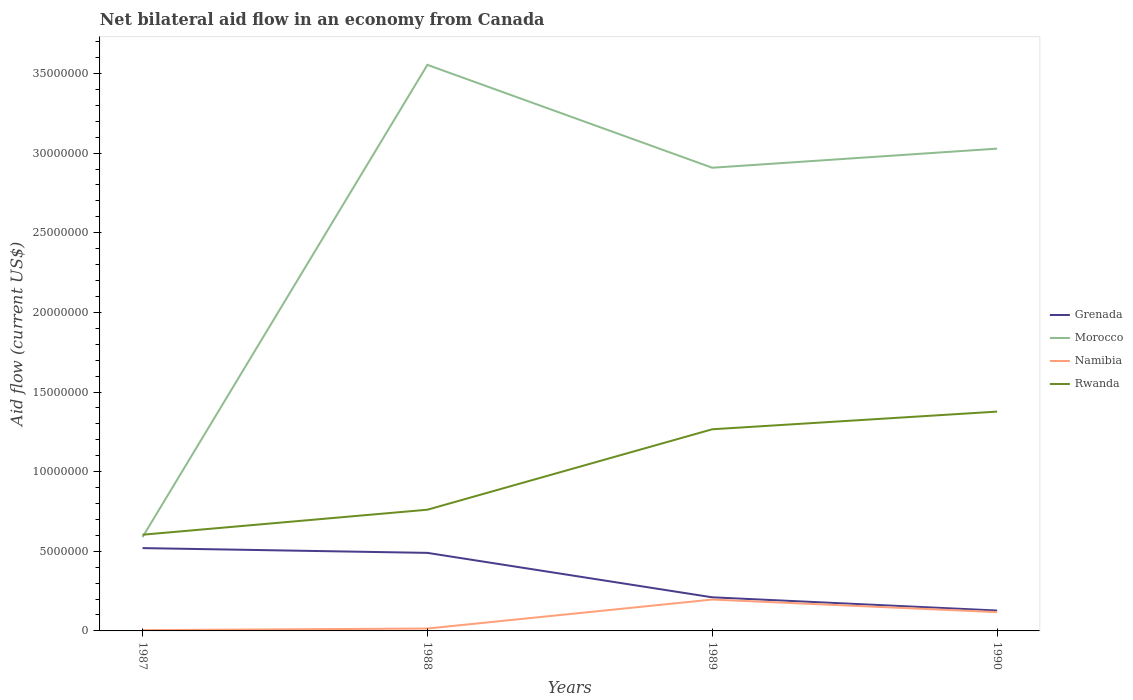Does the line corresponding to Morocco intersect with the line corresponding to Rwanda?
Offer a very short reply. Yes. Across all years, what is the maximum net bilateral aid flow in Rwanda?
Your answer should be very brief. 6.04e+06. What is the total net bilateral aid flow in Namibia in the graph?
Your answer should be very brief. -1.82e+06. What is the difference between the highest and the second highest net bilateral aid flow in Grenada?
Your answer should be compact. 3.92e+06. What is the difference between the highest and the lowest net bilateral aid flow in Namibia?
Offer a terse response. 2. How many years are there in the graph?
Offer a terse response. 4. What is the difference between two consecutive major ticks on the Y-axis?
Provide a succinct answer. 5.00e+06. Are the values on the major ticks of Y-axis written in scientific E-notation?
Keep it short and to the point. No. Does the graph contain any zero values?
Offer a very short reply. No. Where does the legend appear in the graph?
Your answer should be compact. Center right. How many legend labels are there?
Offer a terse response. 4. How are the legend labels stacked?
Offer a very short reply. Vertical. What is the title of the graph?
Make the answer very short. Net bilateral aid flow in an economy from Canada. Does "Congo (Republic)" appear as one of the legend labels in the graph?
Your response must be concise. No. What is the Aid flow (current US$) in Grenada in 1987?
Provide a succinct answer. 5.20e+06. What is the Aid flow (current US$) in Morocco in 1987?
Provide a succinct answer. 5.89e+06. What is the Aid flow (current US$) in Namibia in 1987?
Make the answer very short. 5.00e+04. What is the Aid flow (current US$) of Rwanda in 1987?
Ensure brevity in your answer.  6.04e+06. What is the Aid flow (current US$) of Grenada in 1988?
Make the answer very short. 4.90e+06. What is the Aid flow (current US$) in Morocco in 1988?
Make the answer very short. 3.55e+07. What is the Aid flow (current US$) in Rwanda in 1988?
Offer a very short reply. 7.61e+06. What is the Aid flow (current US$) in Grenada in 1989?
Provide a short and direct response. 2.11e+06. What is the Aid flow (current US$) in Morocco in 1989?
Offer a very short reply. 2.91e+07. What is the Aid flow (current US$) in Namibia in 1989?
Your answer should be compact. 1.97e+06. What is the Aid flow (current US$) of Rwanda in 1989?
Provide a short and direct response. 1.27e+07. What is the Aid flow (current US$) in Grenada in 1990?
Your answer should be compact. 1.28e+06. What is the Aid flow (current US$) in Morocco in 1990?
Provide a short and direct response. 3.03e+07. What is the Aid flow (current US$) in Namibia in 1990?
Offer a terse response. 1.18e+06. What is the Aid flow (current US$) in Rwanda in 1990?
Give a very brief answer. 1.38e+07. Across all years, what is the maximum Aid flow (current US$) of Grenada?
Your response must be concise. 5.20e+06. Across all years, what is the maximum Aid flow (current US$) in Morocco?
Offer a very short reply. 3.55e+07. Across all years, what is the maximum Aid flow (current US$) of Namibia?
Provide a short and direct response. 1.97e+06. Across all years, what is the maximum Aid flow (current US$) in Rwanda?
Ensure brevity in your answer.  1.38e+07. Across all years, what is the minimum Aid flow (current US$) in Grenada?
Provide a short and direct response. 1.28e+06. Across all years, what is the minimum Aid flow (current US$) in Morocco?
Your answer should be very brief. 5.89e+06. Across all years, what is the minimum Aid flow (current US$) in Rwanda?
Provide a succinct answer. 6.04e+06. What is the total Aid flow (current US$) in Grenada in the graph?
Make the answer very short. 1.35e+07. What is the total Aid flow (current US$) in Morocco in the graph?
Provide a succinct answer. 1.01e+08. What is the total Aid flow (current US$) in Namibia in the graph?
Offer a terse response. 3.35e+06. What is the total Aid flow (current US$) in Rwanda in the graph?
Offer a terse response. 4.01e+07. What is the difference between the Aid flow (current US$) of Grenada in 1987 and that in 1988?
Your answer should be compact. 3.00e+05. What is the difference between the Aid flow (current US$) of Morocco in 1987 and that in 1988?
Ensure brevity in your answer.  -2.96e+07. What is the difference between the Aid flow (current US$) in Rwanda in 1987 and that in 1988?
Ensure brevity in your answer.  -1.57e+06. What is the difference between the Aid flow (current US$) in Grenada in 1987 and that in 1989?
Your response must be concise. 3.09e+06. What is the difference between the Aid flow (current US$) of Morocco in 1987 and that in 1989?
Offer a very short reply. -2.32e+07. What is the difference between the Aid flow (current US$) in Namibia in 1987 and that in 1989?
Give a very brief answer. -1.92e+06. What is the difference between the Aid flow (current US$) of Rwanda in 1987 and that in 1989?
Your answer should be very brief. -6.62e+06. What is the difference between the Aid flow (current US$) of Grenada in 1987 and that in 1990?
Offer a terse response. 3.92e+06. What is the difference between the Aid flow (current US$) of Morocco in 1987 and that in 1990?
Your answer should be compact. -2.44e+07. What is the difference between the Aid flow (current US$) of Namibia in 1987 and that in 1990?
Make the answer very short. -1.13e+06. What is the difference between the Aid flow (current US$) of Rwanda in 1987 and that in 1990?
Your answer should be compact. -7.73e+06. What is the difference between the Aid flow (current US$) of Grenada in 1988 and that in 1989?
Give a very brief answer. 2.79e+06. What is the difference between the Aid flow (current US$) of Morocco in 1988 and that in 1989?
Your answer should be very brief. 6.46e+06. What is the difference between the Aid flow (current US$) of Namibia in 1988 and that in 1989?
Keep it short and to the point. -1.82e+06. What is the difference between the Aid flow (current US$) in Rwanda in 1988 and that in 1989?
Provide a short and direct response. -5.05e+06. What is the difference between the Aid flow (current US$) of Grenada in 1988 and that in 1990?
Provide a short and direct response. 3.62e+06. What is the difference between the Aid flow (current US$) of Morocco in 1988 and that in 1990?
Provide a succinct answer. 5.26e+06. What is the difference between the Aid flow (current US$) of Namibia in 1988 and that in 1990?
Provide a short and direct response. -1.03e+06. What is the difference between the Aid flow (current US$) of Rwanda in 1988 and that in 1990?
Your answer should be compact. -6.16e+06. What is the difference between the Aid flow (current US$) of Grenada in 1989 and that in 1990?
Offer a very short reply. 8.30e+05. What is the difference between the Aid flow (current US$) of Morocco in 1989 and that in 1990?
Ensure brevity in your answer.  -1.20e+06. What is the difference between the Aid flow (current US$) of Namibia in 1989 and that in 1990?
Give a very brief answer. 7.90e+05. What is the difference between the Aid flow (current US$) of Rwanda in 1989 and that in 1990?
Your answer should be compact. -1.11e+06. What is the difference between the Aid flow (current US$) in Grenada in 1987 and the Aid flow (current US$) in Morocco in 1988?
Make the answer very short. -3.03e+07. What is the difference between the Aid flow (current US$) in Grenada in 1987 and the Aid flow (current US$) in Namibia in 1988?
Offer a very short reply. 5.05e+06. What is the difference between the Aid flow (current US$) in Grenada in 1987 and the Aid flow (current US$) in Rwanda in 1988?
Provide a short and direct response. -2.41e+06. What is the difference between the Aid flow (current US$) of Morocco in 1987 and the Aid flow (current US$) of Namibia in 1988?
Offer a terse response. 5.74e+06. What is the difference between the Aid flow (current US$) of Morocco in 1987 and the Aid flow (current US$) of Rwanda in 1988?
Give a very brief answer. -1.72e+06. What is the difference between the Aid flow (current US$) in Namibia in 1987 and the Aid flow (current US$) in Rwanda in 1988?
Make the answer very short. -7.56e+06. What is the difference between the Aid flow (current US$) of Grenada in 1987 and the Aid flow (current US$) of Morocco in 1989?
Keep it short and to the point. -2.39e+07. What is the difference between the Aid flow (current US$) of Grenada in 1987 and the Aid flow (current US$) of Namibia in 1989?
Your answer should be very brief. 3.23e+06. What is the difference between the Aid flow (current US$) in Grenada in 1987 and the Aid flow (current US$) in Rwanda in 1989?
Provide a short and direct response. -7.46e+06. What is the difference between the Aid flow (current US$) of Morocco in 1987 and the Aid flow (current US$) of Namibia in 1989?
Your response must be concise. 3.92e+06. What is the difference between the Aid flow (current US$) of Morocco in 1987 and the Aid flow (current US$) of Rwanda in 1989?
Offer a very short reply. -6.77e+06. What is the difference between the Aid flow (current US$) in Namibia in 1987 and the Aid flow (current US$) in Rwanda in 1989?
Offer a terse response. -1.26e+07. What is the difference between the Aid flow (current US$) of Grenada in 1987 and the Aid flow (current US$) of Morocco in 1990?
Your answer should be compact. -2.51e+07. What is the difference between the Aid flow (current US$) in Grenada in 1987 and the Aid flow (current US$) in Namibia in 1990?
Offer a terse response. 4.02e+06. What is the difference between the Aid flow (current US$) in Grenada in 1987 and the Aid flow (current US$) in Rwanda in 1990?
Offer a terse response. -8.57e+06. What is the difference between the Aid flow (current US$) in Morocco in 1987 and the Aid flow (current US$) in Namibia in 1990?
Provide a short and direct response. 4.71e+06. What is the difference between the Aid flow (current US$) of Morocco in 1987 and the Aid flow (current US$) of Rwanda in 1990?
Provide a short and direct response. -7.88e+06. What is the difference between the Aid flow (current US$) in Namibia in 1987 and the Aid flow (current US$) in Rwanda in 1990?
Your answer should be very brief. -1.37e+07. What is the difference between the Aid flow (current US$) in Grenada in 1988 and the Aid flow (current US$) in Morocco in 1989?
Offer a very short reply. -2.42e+07. What is the difference between the Aid flow (current US$) in Grenada in 1988 and the Aid flow (current US$) in Namibia in 1989?
Offer a very short reply. 2.93e+06. What is the difference between the Aid flow (current US$) in Grenada in 1988 and the Aid flow (current US$) in Rwanda in 1989?
Provide a succinct answer. -7.76e+06. What is the difference between the Aid flow (current US$) of Morocco in 1988 and the Aid flow (current US$) of Namibia in 1989?
Provide a succinct answer. 3.36e+07. What is the difference between the Aid flow (current US$) of Morocco in 1988 and the Aid flow (current US$) of Rwanda in 1989?
Give a very brief answer. 2.29e+07. What is the difference between the Aid flow (current US$) of Namibia in 1988 and the Aid flow (current US$) of Rwanda in 1989?
Keep it short and to the point. -1.25e+07. What is the difference between the Aid flow (current US$) in Grenada in 1988 and the Aid flow (current US$) in Morocco in 1990?
Offer a terse response. -2.54e+07. What is the difference between the Aid flow (current US$) in Grenada in 1988 and the Aid flow (current US$) in Namibia in 1990?
Your answer should be very brief. 3.72e+06. What is the difference between the Aid flow (current US$) of Grenada in 1988 and the Aid flow (current US$) of Rwanda in 1990?
Provide a succinct answer. -8.87e+06. What is the difference between the Aid flow (current US$) in Morocco in 1988 and the Aid flow (current US$) in Namibia in 1990?
Make the answer very short. 3.44e+07. What is the difference between the Aid flow (current US$) in Morocco in 1988 and the Aid flow (current US$) in Rwanda in 1990?
Your answer should be compact. 2.18e+07. What is the difference between the Aid flow (current US$) of Namibia in 1988 and the Aid flow (current US$) of Rwanda in 1990?
Offer a very short reply. -1.36e+07. What is the difference between the Aid flow (current US$) of Grenada in 1989 and the Aid flow (current US$) of Morocco in 1990?
Keep it short and to the point. -2.82e+07. What is the difference between the Aid flow (current US$) of Grenada in 1989 and the Aid flow (current US$) of Namibia in 1990?
Your response must be concise. 9.30e+05. What is the difference between the Aid flow (current US$) in Grenada in 1989 and the Aid flow (current US$) in Rwanda in 1990?
Give a very brief answer. -1.17e+07. What is the difference between the Aid flow (current US$) of Morocco in 1989 and the Aid flow (current US$) of Namibia in 1990?
Give a very brief answer. 2.79e+07. What is the difference between the Aid flow (current US$) of Morocco in 1989 and the Aid flow (current US$) of Rwanda in 1990?
Offer a terse response. 1.53e+07. What is the difference between the Aid flow (current US$) in Namibia in 1989 and the Aid flow (current US$) in Rwanda in 1990?
Your response must be concise. -1.18e+07. What is the average Aid flow (current US$) of Grenada per year?
Keep it short and to the point. 3.37e+06. What is the average Aid flow (current US$) of Morocco per year?
Give a very brief answer. 2.52e+07. What is the average Aid flow (current US$) in Namibia per year?
Provide a succinct answer. 8.38e+05. What is the average Aid flow (current US$) in Rwanda per year?
Provide a short and direct response. 1.00e+07. In the year 1987, what is the difference between the Aid flow (current US$) of Grenada and Aid flow (current US$) of Morocco?
Provide a short and direct response. -6.90e+05. In the year 1987, what is the difference between the Aid flow (current US$) of Grenada and Aid flow (current US$) of Namibia?
Ensure brevity in your answer.  5.15e+06. In the year 1987, what is the difference between the Aid flow (current US$) of Grenada and Aid flow (current US$) of Rwanda?
Your answer should be compact. -8.40e+05. In the year 1987, what is the difference between the Aid flow (current US$) in Morocco and Aid flow (current US$) in Namibia?
Ensure brevity in your answer.  5.84e+06. In the year 1987, what is the difference between the Aid flow (current US$) in Namibia and Aid flow (current US$) in Rwanda?
Offer a terse response. -5.99e+06. In the year 1988, what is the difference between the Aid flow (current US$) of Grenada and Aid flow (current US$) of Morocco?
Offer a terse response. -3.06e+07. In the year 1988, what is the difference between the Aid flow (current US$) in Grenada and Aid flow (current US$) in Namibia?
Provide a succinct answer. 4.75e+06. In the year 1988, what is the difference between the Aid flow (current US$) of Grenada and Aid flow (current US$) of Rwanda?
Your response must be concise. -2.71e+06. In the year 1988, what is the difference between the Aid flow (current US$) in Morocco and Aid flow (current US$) in Namibia?
Provide a succinct answer. 3.54e+07. In the year 1988, what is the difference between the Aid flow (current US$) in Morocco and Aid flow (current US$) in Rwanda?
Your response must be concise. 2.79e+07. In the year 1988, what is the difference between the Aid flow (current US$) in Namibia and Aid flow (current US$) in Rwanda?
Your response must be concise. -7.46e+06. In the year 1989, what is the difference between the Aid flow (current US$) in Grenada and Aid flow (current US$) in Morocco?
Give a very brief answer. -2.70e+07. In the year 1989, what is the difference between the Aid flow (current US$) of Grenada and Aid flow (current US$) of Namibia?
Ensure brevity in your answer.  1.40e+05. In the year 1989, what is the difference between the Aid flow (current US$) of Grenada and Aid flow (current US$) of Rwanda?
Give a very brief answer. -1.06e+07. In the year 1989, what is the difference between the Aid flow (current US$) of Morocco and Aid flow (current US$) of Namibia?
Provide a succinct answer. 2.71e+07. In the year 1989, what is the difference between the Aid flow (current US$) in Morocco and Aid flow (current US$) in Rwanda?
Provide a succinct answer. 1.64e+07. In the year 1989, what is the difference between the Aid flow (current US$) in Namibia and Aid flow (current US$) in Rwanda?
Provide a succinct answer. -1.07e+07. In the year 1990, what is the difference between the Aid flow (current US$) in Grenada and Aid flow (current US$) in Morocco?
Give a very brief answer. -2.90e+07. In the year 1990, what is the difference between the Aid flow (current US$) of Grenada and Aid flow (current US$) of Namibia?
Keep it short and to the point. 1.00e+05. In the year 1990, what is the difference between the Aid flow (current US$) in Grenada and Aid flow (current US$) in Rwanda?
Offer a very short reply. -1.25e+07. In the year 1990, what is the difference between the Aid flow (current US$) in Morocco and Aid flow (current US$) in Namibia?
Your answer should be compact. 2.91e+07. In the year 1990, what is the difference between the Aid flow (current US$) of Morocco and Aid flow (current US$) of Rwanda?
Offer a terse response. 1.65e+07. In the year 1990, what is the difference between the Aid flow (current US$) in Namibia and Aid flow (current US$) in Rwanda?
Your answer should be compact. -1.26e+07. What is the ratio of the Aid flow (current US$) in Grenada in 1987 to that in 1988?
Your response must be concise. 1.06. What is the ratio of the Aid flow (current US$) in Morocco in 1987 to that in 1988?
Offer a terse response. 0.17. What is the ratio of the Aid flow (current US$) of Rwanda in 1987 to that in 1988?
Your answer should be very brief. 0.79. What is the ratio of the Aid flow (current US$) of Grenada in 1987 to that in 1989?
Provide a short and direct response. 2.46. What is the ratio of the Aid flow (current US$) in Morocco in 1987 to that in 1989?
Ensure brevity in your answer.  0.2. What is the ratio of the Aid flow (current US$) in Namibia in 1987 to that in 1989?
Offer a very short reply. 0.03. What is the ratio of the Aid flow (current US$) in Rwanda in 1987 to that in 1989?
Your response must be concise. 0.48. What is the ratio of the Aid flow (current US$) in Grenada in 1987 to that in 1990?
Make the answer very short. 4.06. What is the ratio of the Aid flow (current US$) of Morocco in 1987 to that in 1990?
Keep it short and to the point. 0.19. What is the ratio of the Aid flow (current US$) in Namibia in 1987 to that in 1990?
Ensure brevity in your answer.  0.04. What is the ratio of the Aid flow (current US$) in Rwanda in 1987 to that in 1990?
Your response must be concise. 0.44. What is the ratio of the Aid flow (current US$) of Grenada in 1988 to that in 1989?
Keep it short and to the point. 2.32. What is the ratio of the Aid flow (current US$) in Morocco in 1988 to that in 1989?
Provide a succinct answer. 1.22. What is the ratio of the Aid flow (current US$) of Namibia in 1988 to that in 1989?
Offer a terse response. 0.08. What is the ratio of the Aid flow (current US$) in Rwanda in 1988 to that in 1989?
Ensure brevity in your answer.  0.6. What is the ratio of the Aid flow (current US$) in Grenada in 1988 to that in 1990?
Make the answer very short. 3.83. What is the ratio of the Aid flow (current US$) in Morocco in 1988 to that in 1990?
Your response must be concise. 1.17. What is the ratio of the Aid flow (current US$) in Namibia in 1988 to that in 1990?
Provide a succinct answer. 0.13. What is the ratio of the Aid flow (current US$) of Rwanda in 1988 to that in 1990?
Make the answer very short. 0.55. What is the ratio of the Aid flow (current US$) of Grenada in 1989 to that in 1990?
Ensure brevity in your answer.  1.65. What is the ratio of the Aid flow (current US$) of Morocco in 1989 to that in 1990?
Make the answer very short. 0.96. What is the ratio of the Aid flow (current US$) of Namibia in 1989 to that in 1990?
Give a very brief answer. 1.67. What is the ratio of the Aid flow (current US$) in Rwanda in 1989 to that in 1990?
Give a very brief answer. 0.92. What is the difference between the highest and the second highest Aid flow (current US$) of Grenada?
Offer a very short reply. 3.00e+05. What is the difference between the highest and the second highest Aid flow (current US$) of Morocco?
Your answer should be very brief. 5.26e+06. What is the difference between the highest and the second highest Aid flow (current US$) of Namibia?
Make the answer very short. 7.90e+05. What is the difference between the highest and the second highest Aid flow (current US$) in Rwanda?
Your answer should be compact. 1.11e+06. What is the difference between the highest and the lowest Aid flow (current US$) of Grenada?
Provide a succinct answer. 3.92e+06. What is the difference between the highest and the lowest Aid flow (current US$) in Morocco?
Ensure brevity in your answer.  2.96e+07. What is the difference between the highest and the lowest Aid flow (current US$) of Namibia?
Make the answer very short. 1.92e+06. What is the difference between the highest and the lowest Aid flow (current US$) of Rwanda?
Your answer should be compact. 7.73e+06. 